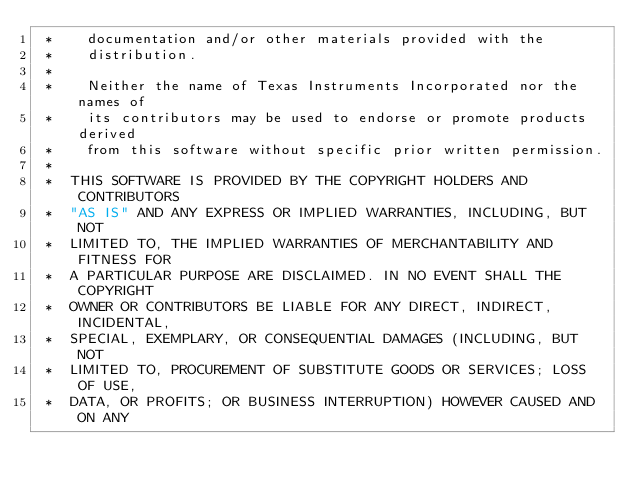Convert code to text. <code><loc_0><loc_0><loc_500><loc_500><_C_> *    documentation and/or other materials provided with the   
 *    distribution.
 *
 *    Neither the name of Texas Instruments Incorporated nor the names of
 *    its contributors may be used to endorse or promote products derived
 *    from this software without specific prior written permission.
 *
 *  THIS SOFTWARE IS PROVIDED BY THE COPYRIGHT HOLDERS AND CONTRIBUTORS 
 *  "AS IS" AND ANY EXPRESS OR IMPLIED WARRANTIES, INCLUDING, BUT NOT 
 *  LIMITED TO, THE IMPLIED WARRANTIES OF MERCHANTABILITY AND FITNESS FOR
 *  A PARTICULAR PURPOSE ARE DISCLAIMED. IN NO EVENT SHALL THE COPYRIGHT 
 *  OWNER OR CONTRIBUTORS BE LIABLE FOR ANY DIRECT, INDIRECT, INCIDENTAL, 
 *  SPECIAL, EXEMPLARY, OR CONSEQUENTIAL DAMAGES (INCLUDING, BUT NOT 
 *  LIMITED TO, PROCUREMENT OF SUBSTITUTE GOODS OR SERVICES; LOSS OF USE,
 *  DATA, OR PROFITS; OR BUSINESS INTERRUPTION) HOWEVER CAUSED AND ON ANY</code> 